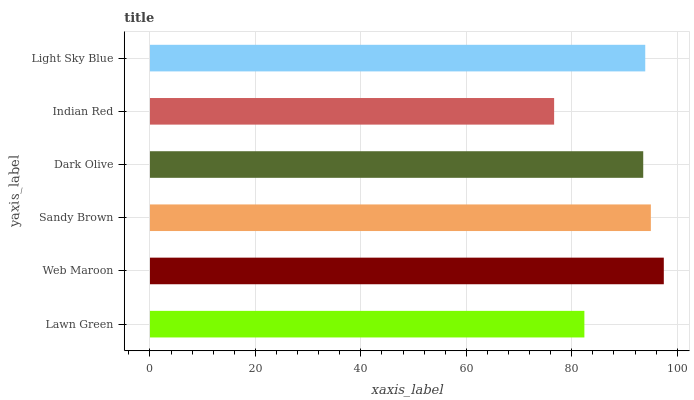Is Indian Red the minimum?
Answer yes or no. Yes. Is Web Maroon the maximum?
Answer yes or no. Yes. Is Sandy Brown the minimum?
Answer yes or no. No. Is Sandy Brown the maximum?
Answer yes or no. No. Is Web Maroon greater than Sandy Brown?
Answer yes or no. Yes. Is Sandy Brown less than Web Maroon?
Answer yes or no. Yes. Is Sandy Brown greater than Web Maroon?
Answer yes or no. No. Is Web Maroon less than Sandy Brown?
Answer yes or no. No. Is Light Sky Blue the high median?
Answer yes or no. Yes. Is Dark Olive the low median?
Answer yes or no. Yes. Is Lawn Green the high median?
Answer yes or no. No. Is Light Sky Blue the low median?
Answer yes or no. No. 